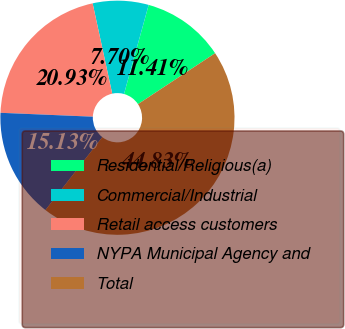<chart> <loc_0><loc_0><loc_500><loc_500><pie_chart><fcel>Residential/Religious(a)<fcel>Commercial/Industrial<fcel>Retail access customers<fcel>NYPA Municipal Agency and<fcel>Total<nl><fcel>11.41%<fcel>7.7%<fcel>20.93%<fcel>15.13%<fcel>44.83%<nl></chart> 